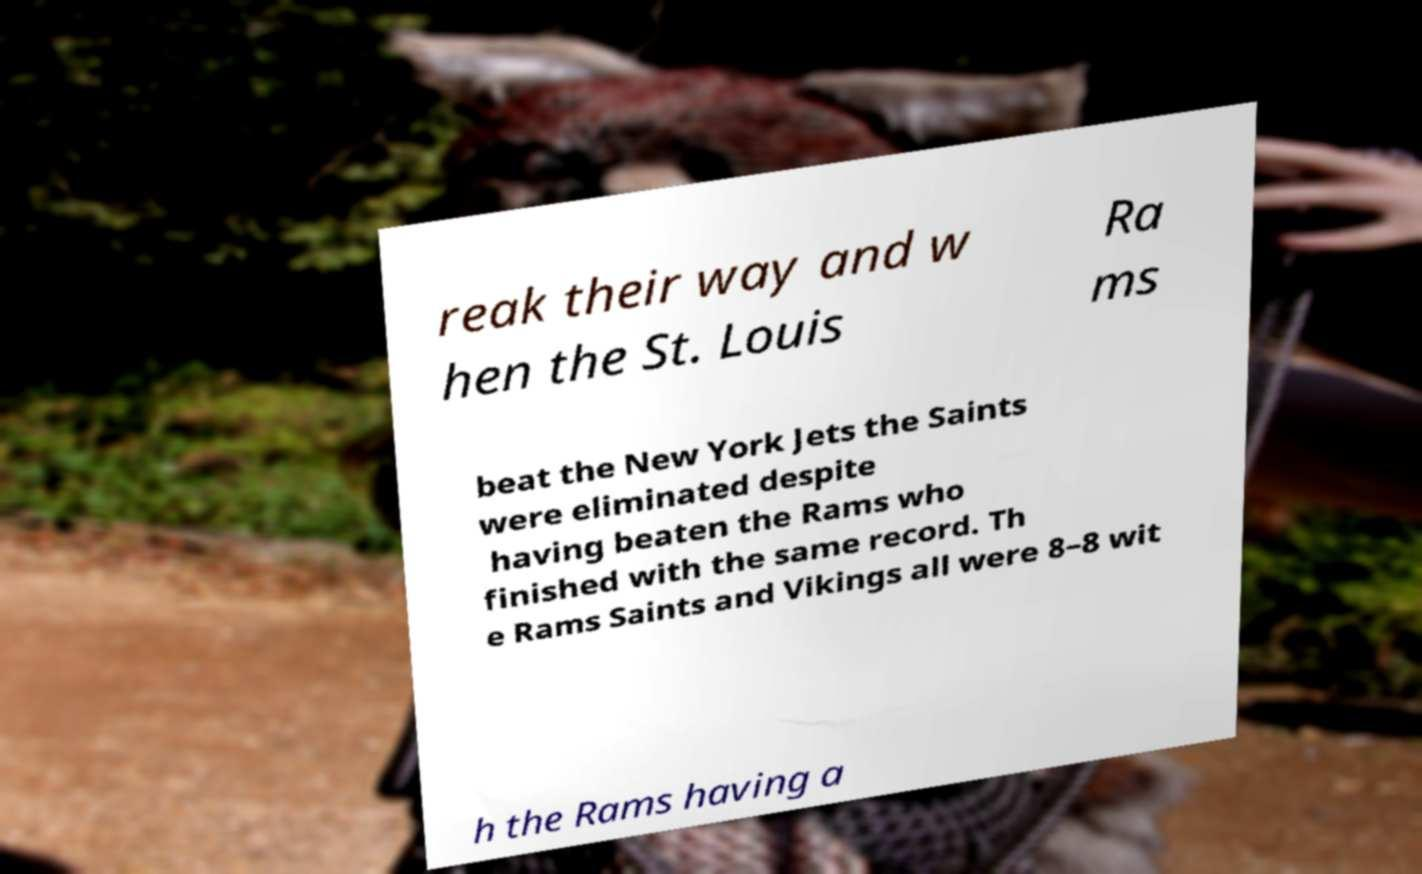Could you assist in decoding the text presented in this image and type it out clearly? reak their way and w hen the St. Louis Ra ms beat the New York Jets the Saints were eliminated despite having beaten the Rams who finished with the same record. Th e Rams Saints and Vikings all were 8–8 wit h the Rams having a 